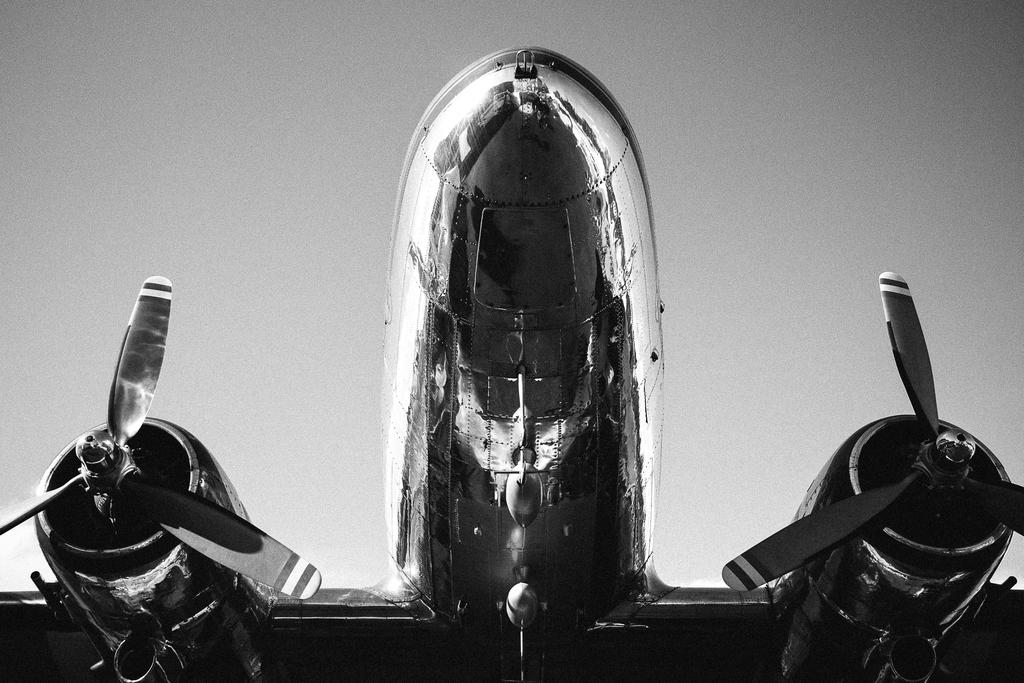What is the perspective of the image? The image shows a bottom view of an aeroplane. What part of the aeroplane is visible in the image? The bottom part of the aeroplane is visible in the image. Can you describe any specific features of the aeroplane's bottom part? Unfortunately, the provided facts do not mention any specific features of the aeroplane's bottom part. How many hens are sitting on the aeroplane's wing in the image? There are no hens present in the image, as it shows a bottom view of an aeroplane. What type of agreement is being signed by the passengers in the image? There are no passengers or agreements present in the image, as it shows a bottom view of an aeroplane. 